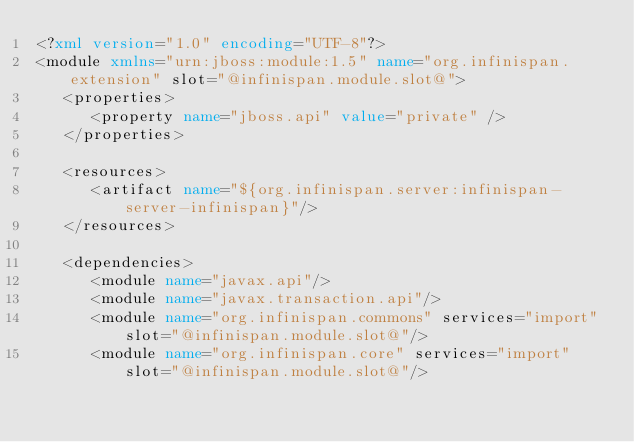Convert code to text. <code><loc_0><loc_0><loc_500><loc_500><_XML_><?xml version="1.0" encoding="UTF-8"?>
<module xmlns="urn:jboss:module:1.5" name="org.infinispan.extension" slot="@infinispan.module.slot@">
   <properties>
      <property name="jboss.api" value="private" />
   </properties>

   <resources>
      <artifact name="${org.infinispan.server:infinispan-server-infinispan}"/>
   </resources>

   <dependencies>
      <module name="javax.api"/>
      <module name="javax.transaction.api"/>
      <module name="org.infinispan.commons" services="import" slot="@infinispan.module.slot@"/>
      <module name="org.infinispan.core" services="import" slot="@infinispan.module.slot@"/></code> 